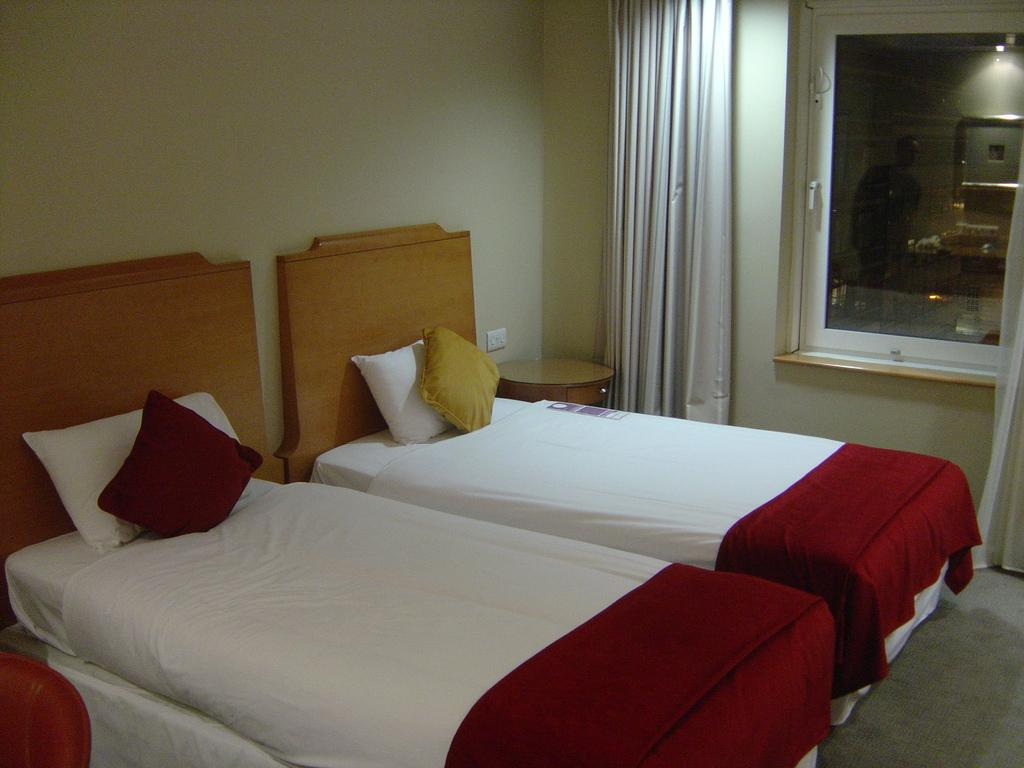How many beds are in the bedroom in the image? There are 2 beds in the bedroom. How many pillows are in the bedroom? There are 2 pillows in the bedroom. What type of window treatment is present in the bedroom? There is a curtain in the bedroom. What architectural feature is present in the bedroom? There is a window in the bedroom. What type of sun is visible through the window in the bedroom? There is no sun visible through the window in the bedroom; the image does not show the outside view. What type of corn is growing in the bedroom? There is no corn present in the bedroom; the image only shows beds, pillows, a curtain, and a window. 